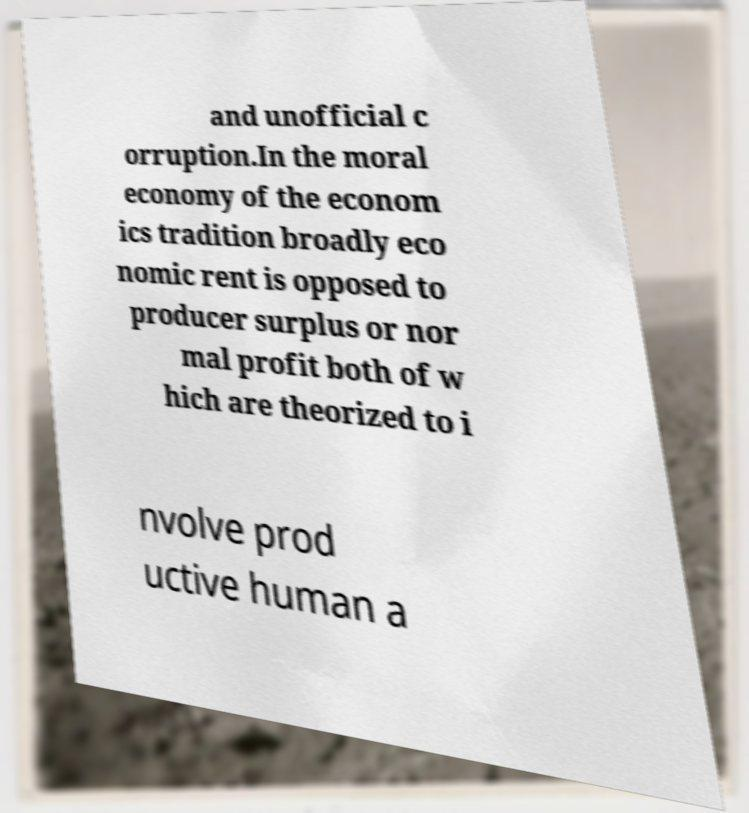For documentation purposes, I need the text within this image transcribed. Could you provide that? and unofficial c orruption.In the moral economy of the econom ics tradition broadly eco nomic rent is opposed to producer surplus or nor mal profit both of w hich are theorized to i nvolve prod uctive human a 